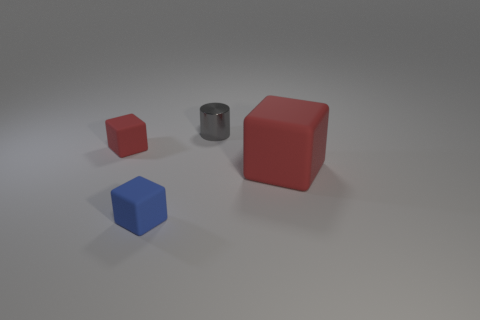Subtract all red matte cubes. How many cubes are left? 1 Add 4 matte cubes. How many objects exist? 8 Subtract all blue cubes. How many cubes are left? 2 Subtract all gray balls. How many green cubes are left? 0 Subtract all cylinders. How many objects are left? 3 Subtract all blue blocks. Subtract all red spheres. How many blocks are left? 2 Add 2 yellow metal things. How many yellow metal things exist? 2 Subtract 0 yellow balls. How many objects are left? 4 Subtract 1 blocks. How many blocks are left? 2 Subtract all small red rubber blocks. Subtract all large blue rubber cubes. How many objects are left? 3 